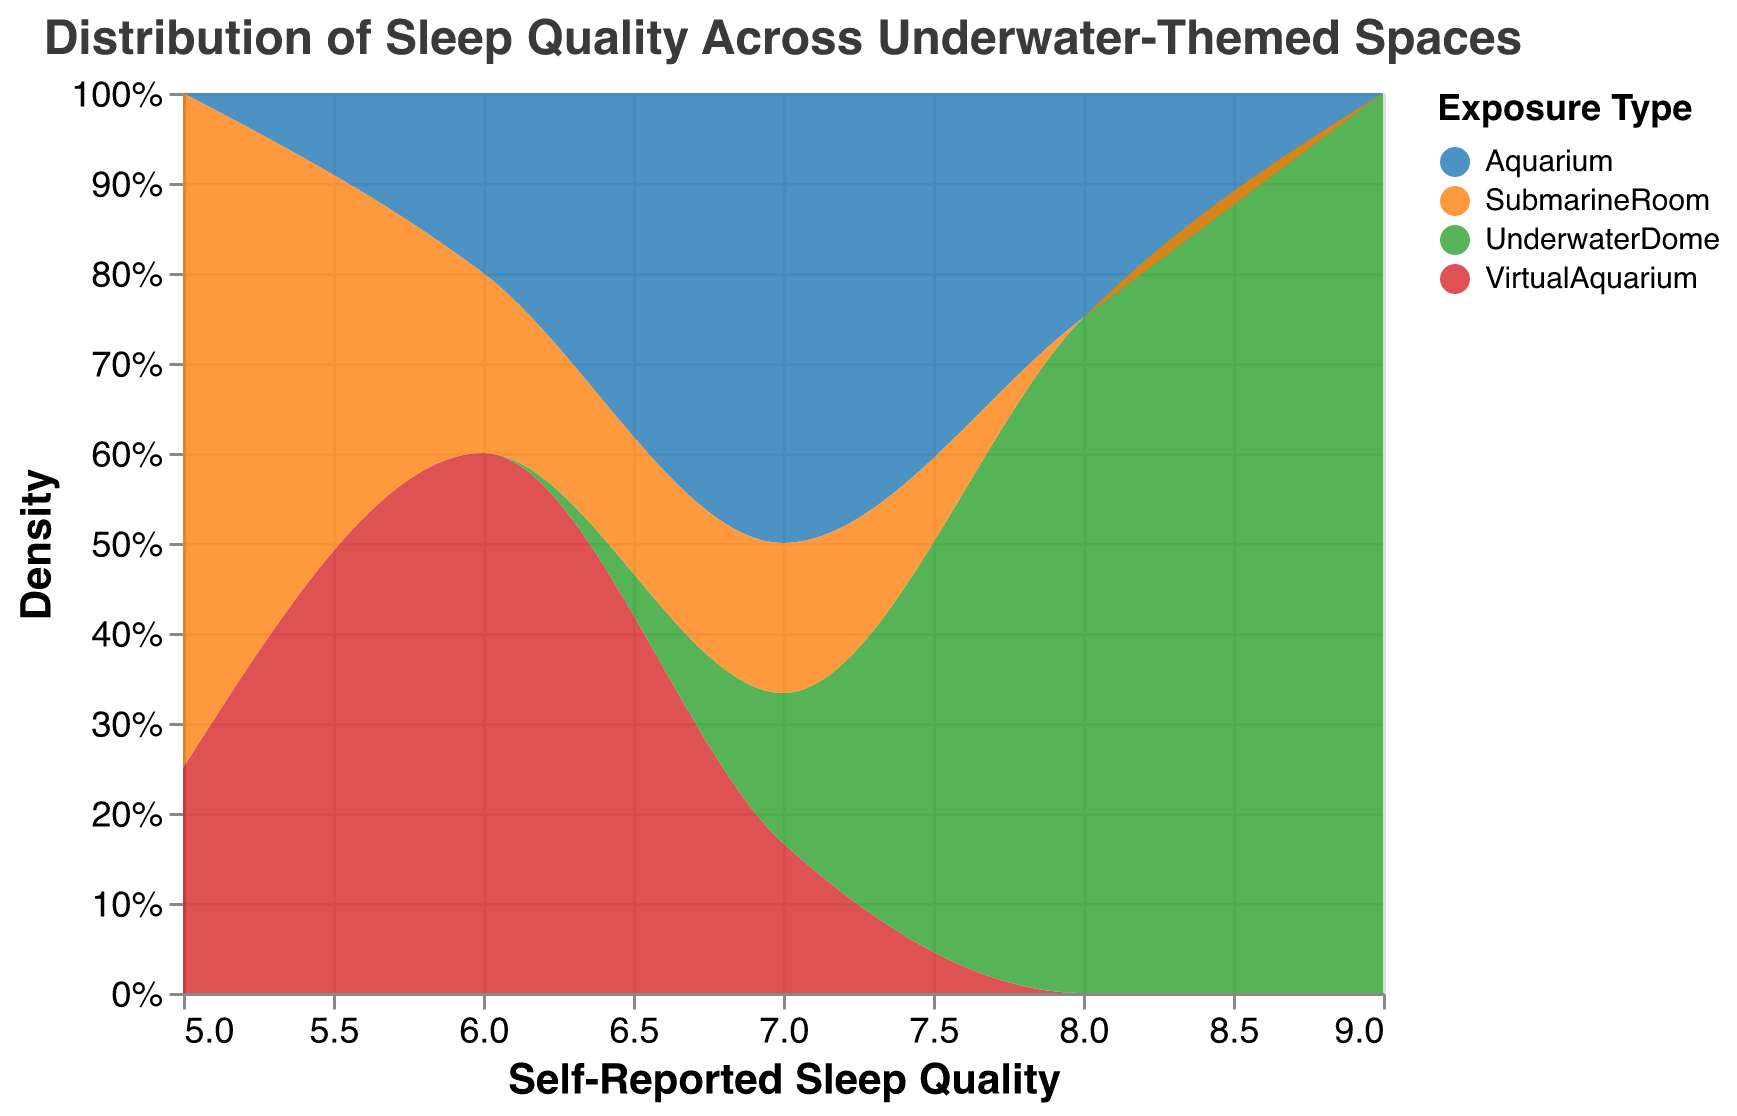What is the title of the figure? The title is usually displayed at the top of the figure and provides a summary of the data presented.
Answer: Distribution of Sleep Quality Across Underwater-Themed Spaces How many different exposure types are represented in the figure? The legend in the plot indicates the exposure types with different color codes.
Answer: Four What self-reported sleep quality score has the highest density for UnderwaterDome? To find this, observe the peak of the area curve for UnderwaterDome. The color-coded areas represent each exposure type.
Answer: Eight Which exposure type has the least frequent occurrence of a sleep quality score of 5? To determine this, look at the color-coded areas at the value of 5 on the x-axis. The exposure type with the smallest segment has the least frequent occurrence.
Answer: VirtualAquarium What is the range of self-reported sleep quality scores shown in the figure? The range can be found by looking at the x-axis, which displays the self-reported sleep quality scores.
Answer: Five to nine Which exposure type shows the broadest distribution of self-reported sleep quality scores? The exposure type with the widest span on the x-axis means it has the broadest distribution. Examine where each color starts and ends.
Answer: UnderwaterDome How does the sleep quality frequency compare between SubmarineRoom and Aquarium at a score of 7? Observe at the score of 7 on the x-axis and compare the heights of the corresponding areas for each exposure type.
Answer: Aquarium has higher frequency at 7 What is the average self-reported sleep quality for the Aquarium exposure type? The average can be calculated by adding all the self-reported scores for Aquarium and then dividing by the number of instances.
Answer: (7+6+8+7+7)/5 = 7 Which exposure type generally results in the highest self-reported sleep quality scores? Compare the peaks and general locations of the different color-coded density areas.
Answer: UnderwaterDome Is there any exposure type where the sleep quality score of 6 appears more frequently than any other scores? For this, check if the height of the area representing any exposure type is highest at 6 compared to other scores.
Answer: No 